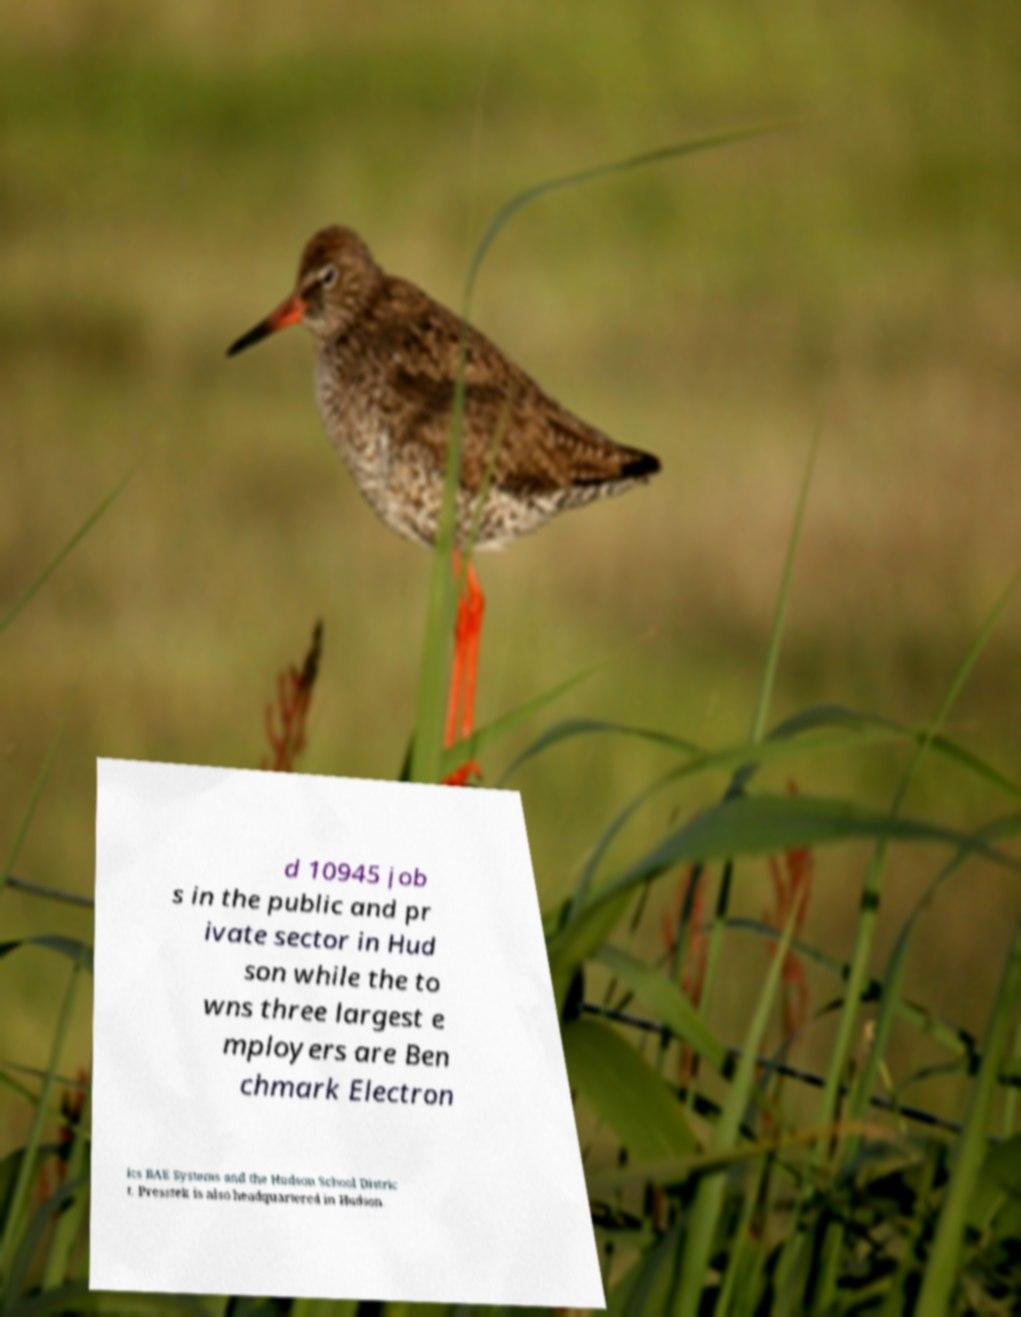For documentation purposes, I need the text within this image transcribed. Could you provide that? d 10945 job s in the public and pr ivate sector in Hud son while the to wns three largest e mployers are Ben chmark Electron ics BAE Systems and the Hudson School Distric t. Presstek is also headquartered in Hudson. 